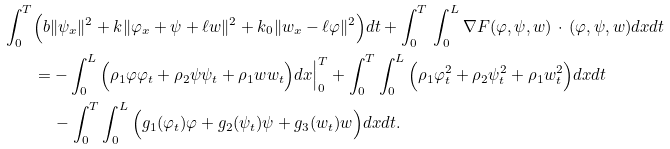<formula> <loc_0><loc_0><loc_500><loc_500>\int _ { 0 } ^ { T } & \Big ( b \| \psi _ { x } \| ^ { 2 } + k \| \varphi _ { x } + \psi + \ell w \| ^ { 2 } + k _ { 0 } \| w _ { x } - \ell \varphi \| ^ { 2 } \Big ) d t + \int _ { 0 } ^ { T } \, \int _ { 0 } ^ { L } \nabla F ( \varphi , \psi , w ) \, \cdot \, ( \varphi , \psi , w ) d x d t \\ & = - \int _ { 0 } ^ { L } \Big ( \rho _ { 1 } \varphi \varphi _ { t } + \rho _ { 2 } \psi \psi _ { t } + \rho _ { 1 } w w _ { t } \Big ) d x \Big | _ { 0 } ^ { T } + \int _ { 0 } ^ { T } \int _ { 0 } ^ { L } \Big ( \rho _ { 1 } \varphi _ { t } ^ { 2 } + \rho _ { 2 } \psi _ { t } ^ { 2 } + \rho _ { 1 } w _ { t } ^ { 2 } \Big ) d x d t \\ & \quad \, - \int _ { 0 } ^ { T } \int _ { 0 } ^ { L } \Big ( g _ { 1 } ( \varphi _ { t } ) \varphi + g _ { 2 } ( \psi _ { t } ) \psi + g _ { 3 } ( w _ { t } ) w \Big ) d x d t .</formula> 